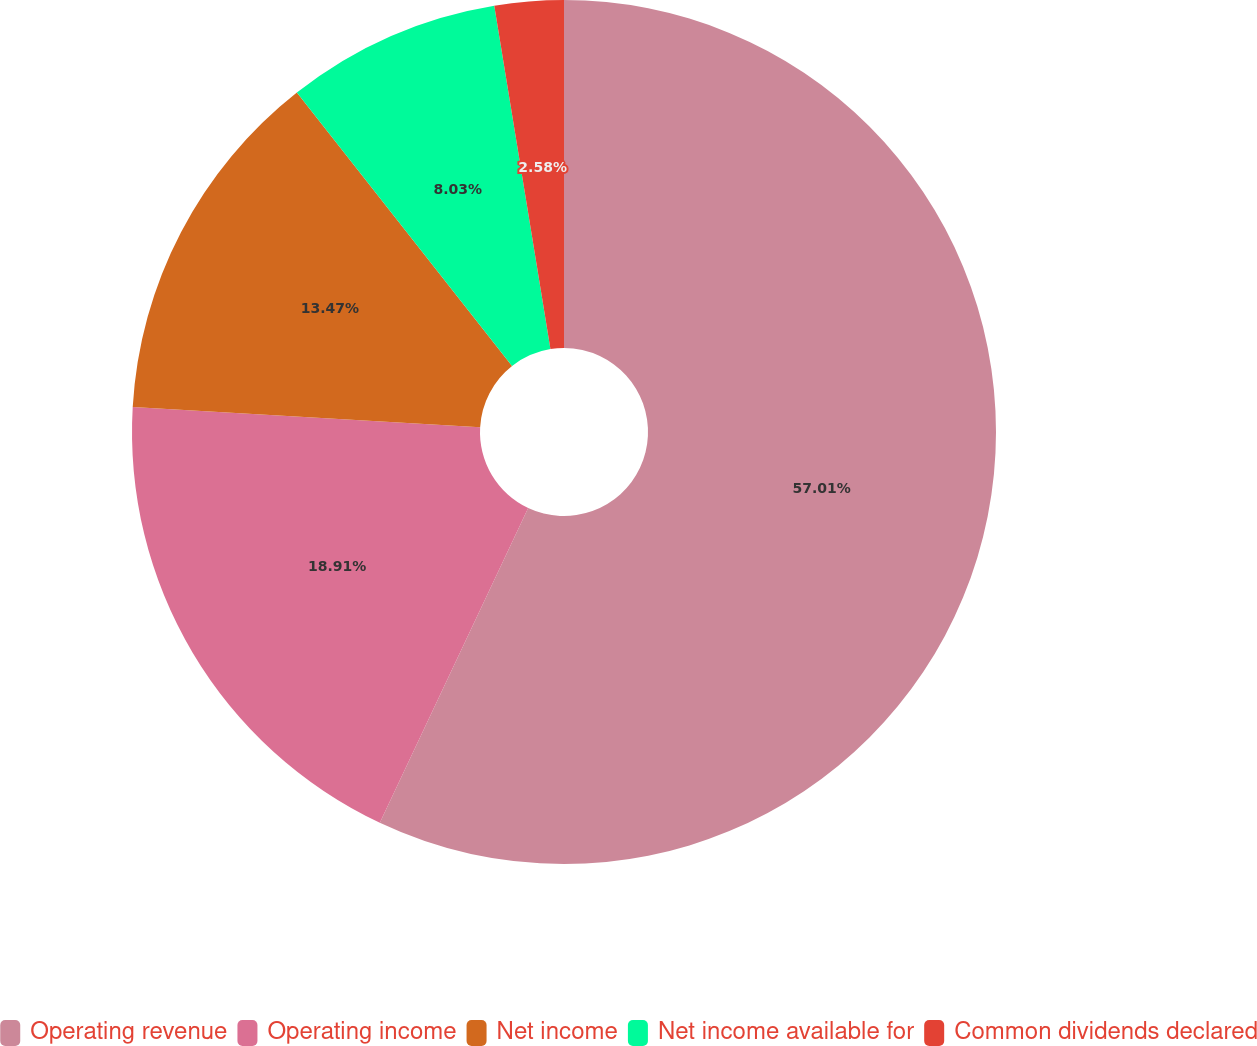Convert chart. <chart><loc_0><loc_0><loc_500><loc_500><pie_chart><fcel>Operating revenue<fcel>Operating income<fcel>Net income<fcel>Net income available for<fcel>Common dividends declared<nl><fcel>57.01%<fcel>18.91%<fcel>13.47%<fcel>8.03%<fcel>2.58%<nl></chart> 